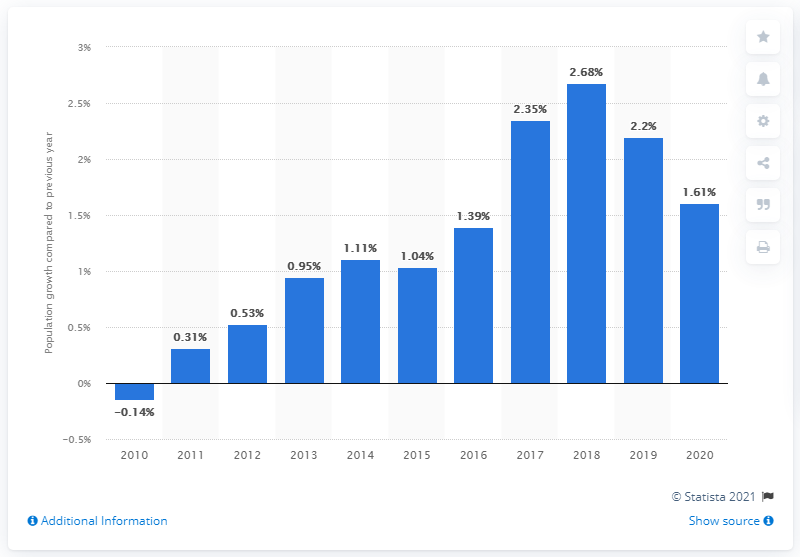Indicate a few pertinent items in this graphic. Iceland's population increased by 1.61% in 2020. 